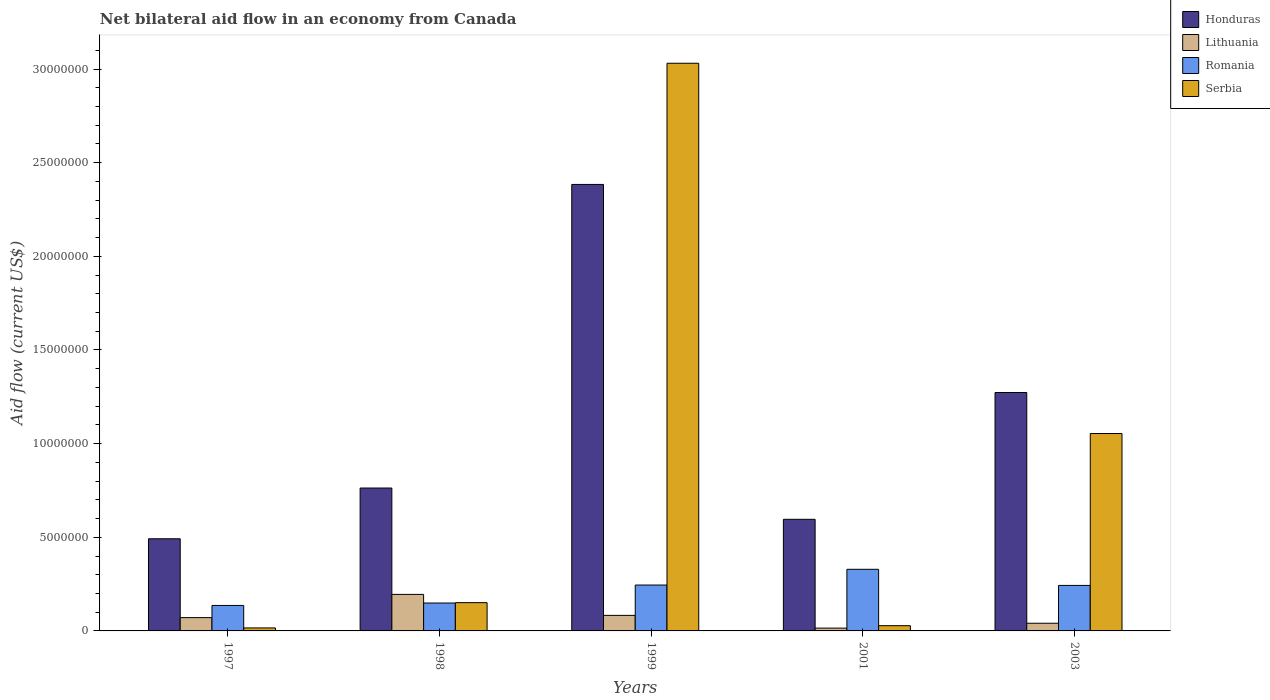How many groups of bars are there?
Offer a terse response. 5. Are the number of bars per tick equal to the number of legend labels?
Offer a very short reply. Yes. How many bars are there on the 4th tick from the left?
Provide a succinct answer. 4. What is the net bilateral aid flow in Serbia in 1999?
Offer a terse response. 3.03e+07. Across all years, what is the maximum net bilateral aid flow in Serbia?
Provide a short and direct response. 3.03e+07. Across all years, what is the minimum net bilateral aid flow in Romania?
Offer a very short reply. 1.36e+06. In which year was the net bilateral aid flow in Lithuania maximum?
Your answer should be compact. 1998. In which year was the net bilateral aid flow in Honduras minimum?
Provide a succinct answer. 1997. What is the total net bilateral aid flow in Serbia in the graph?
Keep it short and to the point. 4.28e+07. What is the difference between the net bilateral aid flow in Serbia in 1997 and that in 1998?
Provide a succinct answer. -1.35e+06. What is the difference between the net bilateral aid flow in Honduras in 2003 and the net bilateral aid flow in Lithuania in 1997?
Your answer should be compact. 1.20e+07. What is the average net bilateral aid flow in Honduras per year?
Your answer should be compact. 1.10e+07. What is the ratio of the net bilateral aid flow in Romania in 1997 to that in 1998?
Offer a very short reply. 0.91. Is the net bilateral aid flow in Serbia in 1999 less than that in 2003?
Your answer should be compact. No. What is the difference between the highest and the second highest net bilateral aid flow in Honduras?
Ensure brevity in your answer.  1.11e+07. What is the difference between the highest and the lowest net bilateral aid flow in Honduras?
Your answer should be compact. 1.89e+07. Is the sum of the net bilateral aid flow in Honduras in 1998 and 2003 greater than the maximum net bilateral aid flow in Serbia across all years?
Your answer should be compact. No. What does the 1st bar from the left in 2001 represents?
Offer a very short reply. Honduras. What does the 4th bar from the right in 1997 represents?
Your response must be concise. Honduras. Is it the case that in every year, the sum of the net bilateral aid flow in Serbia and net bilateral aid flow in Romania is greater than the net bilateral aid flow in Lithuania?
Ensure brevity in your answer.  Yes. How many years are there in the graph?
Ensure brevity in your answer.  5. How many legend labels are there?
Give a very brief answer. 4. What is the title of the graph?
Your response must be concise. Net bilateral aid flow in an economy from Canada. What is the label or title of the X-axis?
Keep it short and to the point. Years. What is the label or title of the Y-axis?
Provide a short and direct response. Aid flow (current US$). What is the Aid flow (current US$) of Honduras in 1997?
Provide a short and direct response. 4.92e+06. What is the Aid flow (current US$) in Lithuania in 1997?
Ensure brevity in your answer.  7.10e+05. What is the Aid flow (current US$) in Romania in 1997?
Make the answer very short. 1.36e+06. What is the Aid flow (current US$) in Serbia in 1997?
Offer a very short reply. 1.60e+05. What is the Aid flow (current US$) of Honduras in 1998?
Your answer should be very brief. 7.63e+06. What is the Aid flow (current US$) in Lithuania in 1998?
Give a very brief answer. 1.95e+06. What is the Aid flow (current US$) in Romania in 1998?
Your answer should be very brief. 1.49e+06. What is the Aid flow (current US$) in Serbia in 1998?
Offer a terse response. 1.51e+06. What is the Aid flow (current US$) in Honduras in 1999?
Give a very brief answer. 2.38e+07. What is the Aid flow (current US$) of Lithuania in 1999?
Your answer should be compact. 8.30e+05. What is the Aid flow (current US$) of Romania in 1999?
Offer a very short reply. 2.45e+06. What is the Aid flow (current US$) of Serbia in 1999?
Offer a very short reply. 3.03e+07. What is the Aid flow (current US$) of Honduras in 2001?
Your answer should be very brief. 5.96e+06. What is the Aid flow (current US$) of Romania in 2001?
Your answer should be very brief. 3.29e+06. What is the Aid flow (current US$) of Honduras in 2003?
Your response must be concise. 1.27e+07. What is the Aid flow (current US$) in Romania in 2003?
Give a very brief answer. 2.43e+06. What is the Aid flow (current US$) in Serbia in 2003?
Give a very brief answer. 1.05e+07. Across all years, what is the maximum Aid flow (current US$) in Honduras?
Keep it short and to the point. 2.38e+07. Across all years, what is the maximum Aid flow (current US$) in Lithuania?
Offer a very short reply. 1.95e+06. Across all years, what is the maximum Aid flow (current US$) in Romania?
Your response must be concise. 3.29e+06. Across all years, what is the maximum Aid flow (current US$) of Serbia?
Make the answer very short. 3.03e+07. Across all years, what is the minimum Aid flow (current US$) in Honduras?
Keep it short and to the point. 4.92e+06. Across all years, what is the minimum Aid flow (current US$) of Romania?
Keep it short and to the point. 1.36e+06. Across all years, what is the minimum Aid flow (current US$) of Serbia?
Keep it short and to the point. 1.60e+05. What is the total Aid flow (current US$) of Honduras in the graph?
Make the answer very short. 5.51e+07. What is the total Aid flow (current US$) in Lithuania in the graph?
Your response must be concise. 4.05e+06. What is the total Aid flow (current US$) in Romania in the graph?
Keep it short and to the point. 1.10e+07. What is the total Aid flow (current US$) of Serbia in the graph?
Make the answer very short. 4.28e+07. What is the difference between the Aid flow (current US$) of Honduras in 1997 and that in 1998?
Make the answer very short. -2.71e+06. What is the difference between the Aid flow (current US$) of Lithuania in 1997 and that in 1998?
Your response must be concise. -1.24e+06. What is the difference between the Aid flow (current US$) of Romania in 1997 and that in 1998?
Your answer should be compact. -1.30e+05. What is the difference between the Aid flow (current US$) in Serbia in 1997 and that in 1998?
Your answer should be very brief. -1.35e+06. What is the difference between the Aid flow (current US$) in Honduras in 1997 and that in 1999?
Make the answer very short. -1.89e+07. What is the difference between the Aid flow (current US$) of Lithuania in 1997 and that in 1999?
Make the answer very short. -1.20e+05. What is the difference between the Aid flow (current US$) of Romania in 1997 and that in 1999?
Your answer should be very brief. -1.09e+06. What is the difference between the Aid flow (current US$) of Serbia in 1997 and that in 1999?
Ensure brevity in your answer.  -3.02e+07. What is the difference between the Aid flow (current US$) in Honduras in 1997 and that in 2001?
Keep it short and to the point. -1.04e+06. What is the difference between the Aid flow (current US$) in Lithuania in 1997 and that in 2001?
Your answer should be very brief. 5.60e+05. What is the difference between the Aid flow (current US$) of Romania in 1997 and that in 2001?
Ensure brevity in your answer.  -1.93e+06. What is the difference between the Aid flow (current US$) in Serbia in 1997 and that in 2001?
Offer a terse response. -1.20e+05. What is the difference between the Aid flow (current US$) in Honduras in 1997 and that in 2003?
Offer a terse response. -7.81e+06. What is the difference between the Aid flow (current US$) of Romania in 1997 and that in 2003?
Your response must be concise. -1.07e+06. What is the difference between the Aid flow (current US$) of Serbia in 1997 and that in 2003?
Keep it short and to the point. -1.04e+07. What is the difference between the Aid flow (current US$) in Honduras in 1998 and that in 1999?
Offer a very short reply. -1.62e+07. What is the difference between the Aid flow (current US$) in Lithuania in 1998 and that in 1999?
Provide a short and direct response. 1.12e+06. What is the difference between the Aid flow (current US$) in Romania in 1998 and that in 1999?
Give a very brief answer. -9.60e+05. What is the difference between the Aid flow (current US$) of Serbia in 1998 and that in 1999?
Ensure brevity in your answer.  -2.88e+07. What is the difference between the Aid flow (current US$) of Honduras in 1998 and that in 2001?
Your response must be concise. 1.67e+06. What is the difference between the Aid flow (current US$) in Lithuania in 1998 and that in 2001?
Make the answer very short. 1.80e+06. What is the difference between the Aid flow (current US$) in Romania in 1998 and that in 2001?
Your answer should be compact. -1.80e+06. What is the difference between the Aid flow (current US$) of Serbia in 1998 and that in 2001?
Your response must be concise. 1.23e+06. What is the difference between the Aid flow (current US$) of Honduras in 1998 and that in 2003?
Keep it short and to the point. -5.10e+06. What is the difference between the Aid flow (current US$) in Lithuania in 1998 and that in 2003?
Your answer should be compact. 1.54e+06. What is the difference between the Aid flow (current US$) of Romania in 1998 and that in 2003?
Your answer should be very brief. -9.40e+05. What is the difference between the Aid flow (current US$) of Serbia in 1998 and that in 2003?
Keep it short and to the point. -9.03e+06. What is the difference between the Aid flow (current US$) of Honduras in 1999 and that in 2001?
Your answer should be very brief. 1.79e+07. What is the difference between the Aid flow (current US$) of Lithuania in 1999 and that in 2001?
Your answer should be compact. 6.80e+05. What is the difference between the Aid flow (current US$) in Romania in 1999 and that in 2001?
Make the answer very short. -8.40e+05. What is the difference between the Aid flow (current US$) of Serbia in 1999 and that in 2001?
Keep it short and to the point. 3.00e+07. What is the difference between the Aid flow (current US$) in Honduras in 1999 and that in 2003?
Your response must be concise. 1.11e+07. What is the difference between the Aid flow (current US$) of Lithuania in 1999 and that in 2003?
Offer a very short reply. 4.20e+05. What is the difference between the Aid flow (current US$) of Romania in 1999 and that in 2003?
Keep it short and to the point. 2.00e+04. What is the difference between the Aid flow (current US$) in Serbia in 1999 and that in 2003?
Your response must be concise. 1.98e+07. What is the difference between the Aid flow (current US$) in Honduras in 2001 and that in 2003?
Your answer should be compact. -6.77e+06. What is the difference between the Aid flow (current US$) in Romania in 2001 and that in 2003?
Provide a succinct answer. 8.60e+05. What is the difference between the Aid flow (current US$) of Serbia in 2001 and that in 2003?
Keep it short and to the point. -1.03e+07. What is the difference between the Aid flow (current US$) in Honduras in 1997 and the Aid flow (current US$) in Lithuania in 1998?
Offer a very short reply. 2.97e+06. What is the difference between the Aid flow (current US$) in Honduras in 1997 and the Aid flow (current US$) in Romania in 1998?
Offer a terse response. 3.43e+06. What is the difference between the Aid flow (current US$) in Honduras in 1997 and the Aid flow (current US$) in Serbia in 1998?
Your answer should be compact. 3.41e+06. What is the difference between the Aid flow (current US$) in Lithuania in 1997 and the Aid flow (current US$) in Romania in 1998?
Give a very brief answer. -7.80e+05. What is the difference between the Aid flow (current US$) of Lithuania in 1997 and the Aid flow (current US$) of Serbia in 1998?
Your response must be concise. -8.00e+05. What is the difference between the Aid flow (current US$) in Romania in 1997 and the Aid flow (current US$) in Serbia in 1998?
Keep it short and to the point. -1.50e+05. What is the difference between the Aid flow (current US$) in Honduras in 1997 and the Aid flow (current US$) in Lithuania in 1999?
Give a very brief answer. 4.09e+06. What is the difference between the Aid flow (current US$) in Honduras in 1997 and the Aid flow (current US$) in Romania in 1999?
Your response must be concise. 2.47e+06. What is the difference between the Aid flow (current US$) in Honduras in 1997 and the Aid flow (current US$) in Serbia in 1999?
Offer a terse response. -2.54e+07. What is the difference between the Aid flow (current US$) of Lithuania in 1997 and the Aid flow (current US$) of Romania in 1999?
Give a very brief answer. -1.74e+06. What is the difference between the Aid flow (current US$) in Lithuania in 1997 and the Aid flow (current US$) in Serbia in 1999?
Provide a short and direct response. -2.96e+07. What is the difference between the Aid flow (current US$) in Romania in 1997 and the Aid flow (current US$) in Serbia in 1999?
Provide a short and direct response. -2.90e+07. What is the difference between the Aid flow (current US$) of Honduras in 1997 and the Aid flow (current US$) of Lithuania in 2001?
Your answer should be compact. 4.77e+06. What is the difference between the Aid flow (current US$) of Honduras in 1997 and the Aid flow (current US$) of Romania in 2001?
Provide a succinct answer. 1.63e+06. What is the difference between the Aid flow (current US$) of Honduras in 1997 and the Aid flow (current US$) of Serbia in 2001?
Give a very brief answer. 4.64e+06. What is the difference between the Aid flow (current US$) of Lithuania in 1997 and the Aid flow (current US$) of Romania in 2001?
Your answer should be compact. -2.58e+06. What is the difference between the Aid flow (current US$) in Lithuania in 1997 and the Aid flow (current US$) in Serbia in 2001?
Your answer should be very brief. 4.30e+05. What is the difference between the Aid flow (current US$) in Romania in 1997 and the Aid flow (current US$) in Serbia in 2001?
Your response must be concise. 1.08e+06. What is the difference between the Aid flow (current US$) of Honduras in 1997 and the Aid flow (current US$) of Lithuania in 2003?
Make the answer very short. 4.51e+06. What is the difference between the Aid flow (current US$) in Honduras in 1997 and the Aid flow (current US$) in Romania in 2003?
Ensure brevity in your answer.  2.49e+06. What is the difference between the Aid flow (current US$) of Honduras in 1997 and the Aid flow (current US$) of Serbia in 2003?
Make the answer very short. -5.62e+06. What is the difference between the Aid flow (current US$) in Lithuania in 1997 and the Aid flow (current US$) in Romania in 2003?
Ensure brevity in your answer.  -1.72e+06. What is the difference between the Aid flow (current US$) of Lithuania in 1997 and the Aid flow (current US$) of Serbia in 2003?
Offer a terse response. -9.83e+06. What is the difference between the Aid flow (current US$) of Romania in 1997 and the Aid flow (current US$) of Serbia in 2003?
Ensure brevity in your answer.  -9.18e+06. What is the difference between the Aid flow (current US$) in Honduras in 1998 and the Aid flow (current US$) in Lithuania in 1999?
Your response must be concise. 6.80e+06. What is the difference between the Aid flow (current US$) of Honduras in 1998 and the Aid flow (current US$) of Romania in 1999?
Your response must be concise. 5.18e+06. What is the difference between the Aid flow (current US$) in Honduras in 1998 and the Aid flow (current US$) in Serbia in 1999?
Make the answer very short. -2.27e+07. What is the difference between the Aid flow (current US$) of Lithuania in 1998 and the Aid flow (current US$) of Romania in 1999?
Ensure brevity in your answer.  -5.00e+05. What is the difference between the Aid flow (current US$) of Lithuania in 1998 and the Aid flow (current US$) of Serbia in 1999?
Offer a very short reply. -2.84e+07. What is the difference between the Aid flow (current US$) in Romania in 1998 and the Aid flow (current US$) in Serbia in 1999?
Provide a succinct answer. -2.88e+07. What is the difference between the Aid flow (current US$) of Honduras in 1998 and the Aid flow (current US$) of Lithuania in 2001?
Give a very brief answer. 7.48e+06. What is the difference between the Aid flow (current US$) in Honduras in 1998 and the Aid flow (current US$) in Romania in 2001?
Offer a terse response. 4.34e+06. What is the difference between the Aid flow (current US$) of Honduras in 1998 and the Aid flow (current US$) of Serbia in 2001?
Give a very brief answer. 7.35e+06. What is the difference between the Aid flow (current US$) in Lithuania in 1998 and the Aid flow (current US$) in Romania in 2001?
Provide a short and direct response. -1.34e+06. What is the difference between the Aid flow (current US$) in Lithuania in 1998 and the Aid flow (current US$) in Serbia in 2001?
Your answer should be very brief. 1.67e+06. What is the difference between the Aid flow (current US$) of Romania in 1998 and the Aid flow (current US$) of Serbia in 2001?
Offer a terse response. 1.21e+06. What is the difference between the Aid flow (current US$) of Honduras in 1998 and the Aid flow (current US$) of Lithuania in 2003?
Your response must be concise. 7.22e+06. What is the difference between the Aid flow (current US$) of Honduras in 1998 and the Aid flow (current US$) of Romania in 2003?
Offer a terse response. 5.20e+06. What is the difference between the Aid flow (current US$) in Honduras in 1998 and the Aid flow (current US$) in Serbia in 2003?
Provide a succinct answer. -2.91e+06. What is the difference between the Aid flow (current US$) in Lithuania in 1998 and the Aid flow (current US$) in Romania in 2003?
Offer a very short reply. -4.80e+05. What is the difference between the Aid flow (current US$) of Lithuania in 1998 and the Aid flow (current US$) of Serbia in 2003?
Your response must be concise. -8.59e+06. What is the difference between the Aid flow (current US$) of Romania in 1998 and the Aid flow (current US$) of Serbia in 2003?
Give a very brief answer. -9.05e+06. What is the difference between the Aid flow (current US$) in Honduras in 1999 and the Aid flow (current US$) in Lithuania in 2001?
Give a very brief answer. 2.37e+07. What is the difference between the Aid flow (current US$) in Honduras in 1999 and the Aid flow (current US$) in Romania in 2001?
Make the answer very short. 2.06e+07. What is the difference between the Aid flow (current US$) in Honduras in 1999 and the Aid flow (current US$) in Serbia in 2001?
Your answer should be compact. 2.36e+07. What is the difference between the Aid flow (current US$) in Lithuania in 1999 and the Aid flow (current US$) in Romania in 2001?
Offer a very short reply. -2.46e+06. What is the difference between the Aid flow (current US$) of Lithuania in 1999 and the Aid flow (current US$) of Serbia in 2001?
Keep it short and to the point. 5.50e+05. What is the difference between the Aid flow (current US$) in Romania in 1999 and the Aid flow (current US$) in Serbia in 2001?
Your response must be concise. 2.17e+06. What is the difference between the Aid flow (current US$) of Honduras in 1999 and the Aid flow (current US$) of Lithuania in 2003?
Make the answer very short. 2.34e+07. What is the difference between the Aid flow (current US$) in Honduras in 1999 and the Aid flow (current US$) in Romania in 2003?
Keep it short and to the point. 2.14e+07. What is the difference between the Aid flow (current US$) in Honduras in 1999 and the Aid flow (current US$) in Serbia in 2003?
Provide a short and direct response. 1.33e+07. What is the difference between the Aid flow (current US$) in Lithuania in 1999 and the Aid flow (current US$) in Romania in 2003?
Make the answer very short. -1.60e+06. What is the difference between the Aid flow (current US$) in Lithuania in 1999 and the Aid flow (current US$) in Serbia in 2003?
Your response must be concise. -9.71e+06. What is the difference between the Aid flow (current US$) in Romania in 1999 and the Aid flow (current US$) in Serbia in 2003?
Your answer should be compact. -8.09e+06. What is the difference between the Aid flow (current US$) in Honduras in 2001 and the Aid flow (current US$) in Lithuania in 2003?
Offer a very short reply. 5.55e+06. What is the difference between the Aid flow (current US$) of Honduras in 2001 and the Aid flow (current US$) of Romania in 2003?
Give a very brief answer. 3.53e+06. What is the difference between the Aid flow (current US$) of Honduras in 2001 and the Aid flow (current US$) of Serbia in 2003?
Your answer should be very brief. -4.58e+06. What is the difference between the Aid flow (current US$) in Lithuania in 2001 and the Aid flow (current US$) in Romania in 2003?
Offer a very short reply. -2.28e+06. What is the difference between the Aid flow (current US$) in Lithuania in 2001 and the Aid flow (current US$) in Serbia in 2003?
Your response must be concise. -1.04e+07. What is the difference between the Aid flow (current US$) of Romania in 2001 and the Aid flow (current US$) of Serbia in 2003?
Offer a very short reply. -7.25e+06. What is the average Aid flow (current US$) in Honduras per year?
Keep it short and to the point. 1.10e+07. What is the average Aid flow (current US$) of Lithuania per year?
Give a very brief answer. 8.10e+05. What is the average Aid flow (current US$) in Romania per year?
Offer a terse response. 2.20e+06. What is the average Aid flow (current US$) in Serbia per year?
Offer a very short reply. 8.56e+06. In the year 1997, what is the difference between the Aid flow (current US$) of Honduras and Aid flow (current US$) of Lithuania?
Make the answer very short. 4.21e+06. In the year 1997, what is the difference between the Aid flow (current US$) in Honduras and Aid flow (current US$) in Romania?
Your answer should be compact. 3.56e+06. In the year 1997, what is the difference between the Aid flow (current US$) of Honduras and Aid flow (current US$) of Serbia?
Ensure brevity in your answer.  4.76e+06. In the year 1997, what is the difference between the Aid flow (current US$) in Lithuania and Aid flow (current US$) in Romania?
Keep it short and to the point. -6.50e+05. In the year 1997, what is the difference between the Aid flow (current US$) of Lithuania and Aid flow (current US$) of Serbia?
Offer a very short reply. 5.50e+05. In the year 1997, what is the difference between the Aid flow (current US$) in Romania and Aid flow (current US$) in Serbia?
Make the answer very short. 1.20e+06. In the year 1998, what is the difference between the Aid flow (current US$) in Honduras and Aid flow (current US$) in Lithuania?
Provide a short and direct response. 5.68e+06. In the year 1998, what is the difference between the Aid flow (current US$) of Honduras and Aid flow (current US$) of Romania?
Your answer should be compact. 6.14e+06. In the year 1998, what is the difference between the Aid flow (current US$) in Honduras and Aid flow (current US$) in Serbia?
Provide a succinct answer. 6.12e+06. In the year 1998, what is the difference between the Aid flow (current US$) in Romania and Aid flow (current US$) in Serbia?
Make the answer very short. -2.00e+04. In the year 1999, what is the difference between the Aid flow (current US$) of Honduras and Aid flow (current US$) of Lithuania?
Make the answer very short. 2.30e+07. In the year 1999, what is the difference between the Aid flow (current US$) of Honduras and Aid flow (current US$) of Romania?
Give a very brief answer. 2.14e+07. In the year 1999, what is the difference between the Aid flow (current US$) in Honduras and Aid flow (current US$) in Serbia?
Make the answer very short. -6.47e+06. In the year 1999, what is the difference between the Aid flow (current US$) of Lithuania and Aid flow (current US$) of Romania?
Ensure brevity in your answer.  -1.62e+06. In the year 1999, what is the difference between the Aid flow (current US$) in Lithuania and Aid flow (current US$) in Serbia?
Offer a very short reply. -2.95e+07. In the year 1999, what is the difference between the Aid flow (current US$) in Romania and Aid flow (current US$) in Serbia?
Ensure brevity in your answer.  -2.79e+07. In the year 2001, what is the difference between the Aid flow (current US$) of Honduras and Aid flow (current US$) of Lithuania?
Offer a terse response. 5.81e+06. In the year 2001, what is the difference between the Aid flow (current US$) of Honduras and Aid flow (current US$) of Romania?
Keep it short and to the point. 2.67e+06. In the year 2001, what is the difference between the Aid flow (current US$) of Honduras and Aid flow (current US$) of Serbia?
Give a very brief answer. 5.68e+06. In the year 2001, what is the difference between the Aid flow (current US$) of Lithuania and Aid flow (current US$) of Romania?
Offer a terse response. -3.14e+06. In the year 2001, what is the difference between the Aid flow (current US$) of Lithuania and Aid flow (current US$) of Serbia?
Give a very brief answer. -1.30e+05. In the year 2001, what is the difference between the Aid flow (current US$) of Romania and Aid flow (current US$) of Serbia?
Offer a terse response. 3.01e+06. In the year 2003, what is the difference between the Aid flow (current US$) of Honduras and Aid flow (current US$) of Lithuania?
Provide a succinct answer. 1.23e+07. In the year 2003, what is the difference between the Aid flow (current US$) of Honduras and Aid flow (current US$) of Romania?
Your answer should be very brief. 1.03e+07. In the year 2003, what is the difference between the Aid flow (current US$) of Honduras and Aid flow (current US$) of Serbia?
Make the answer very short. 2.19e+06. In the year 2003, what is the difference between the Aid flow (current US$) in Lithuania and Aid flow (current US$) in Romania?
Your answer should be very brief. -2.02e+06. In the year 2003, what is the difference between the Aid flow (current US$) in Lithuania and Aid flow (current US$) in Serbia?
Keep it short and to the point. -1.01e+07. In the year 2003, what is the difference between the Aid flow (current US$) of Romania and Aid flow (current US$) of Serbia?
Offer a very short reply. -8.11e+06. What is the ratio of the Aid flow (current US$) in Honduras in 1997 to that in 1998?
Offer a terse response. 0.64. What is the ratio of the Aid flow (current US$) of Lithuania in 1997 to that in 1998?
Your response must be concise. 0.36. What is the ratio of the Aid flow (current US$) in Romania in 1997 to that in 1998?
Keep it short and to the point. 0.91. What is the ratio of the Aid flow (current US$) of Serbia in 1997 to that in 1998?
Your response must be concise. 0.11. What is the ratio of the Aid flow (current US$) of Honduras in 1997 to that in 1999?
Your response must be concise. 0.21. What is the ratio of the Aid flow (current US$) of Lithuania in 1997 to that in 1999?
Your answer should be very brief. 0.86. What is the ratio of the Aid flow (current US$) of Romania in 1997 to that in 1999?
Offer a very short reply. 0.56. What is the ratio of the Aid flow (current US$) of Serbia in 1997 to that in 1999?
Your answer should be very brief. 0.01. What is the ratio of the Aid flow (current US$) of Honduras in 1997 to that in 2001?
Offer a terse response. 0.83. What is the ratio of the Aid flow (current US$) of Lithuania in 1997 to that in 2001?
Keep it short and to the point. 4.73. What is the ratio of the Aid flow (current US$) of Romania in 1997 to that in 2001?
Provide a short and direct response. 0.41. What is the ratio of the Aid flow (current US$) of Serbia in 1997 to that in 2001?
Your answer should be very brief. 0.57. What is the ratio of the Aid flow (current US$) in Honduras in 1997 to that in 2003?
Offer a very short reply. 0.39. What is the ratio of the Aid flow (current US$) in Lithuania in 1997 to that in 2003?
Offer a terse response. 1.73. What is the ratio of the Aid flow (current US$) of Romania in 1997 to that in 2003?
Your answer should be very brief. 0.56. What is the ratio of the Aid flow (current US$) of Serbia in 1997 to that in 2003?
Ensure brevity in your answer.  0.02. What is the ratio of the Aid flow (current US$) in Honduras in 1998 to that in 1999?
Provide a succinct answer. 0.32. What is the ratio of the Aid flow (current US$) in Lithuania in 1998 to that in 1999?
Offer a very short reply. 2.35. What is the ratio of the Aid flow (current US$) of Romania in 1998 to that in 1999?
Ensure brevity in your answer.  0.61. What is the ratio of the Aid flow (current US$) in Serbia in 1998 to that in 1999?
Give a very brief answer. 0.05. What is the ratio of the Aid flow (current US$) of Honduras in 1998 to that in 2001?
Give a very brief answer. 1.28. What is the ratio of the Aid flow (current US$) of Romania in 1998 to that in 2001?
Ensure brevity in your answer.  0.45. What is the ratio of the Aid flow (current US$) in Serbia in 1998 to that in 2001?
Offer a very short reply. 5.39. What is the ratio of the Aid flow (current US$) in Honduras in 1998 to that in 2003?
Your answer should be compact. 0.6. What is the ratio of the Aid flow (current US$) of Lithuania in 1998 to that in 2003?
Your answer should be very brief. 4.76. What is the ratio of the Aid flow (current US$) of Romania in 1998 to that in 2003?
Provide a succinct answer. 0.61. What is the ratio of the Aid flow (current US$) in Serbia in 1998 to that in 2003?
Offer a terse response. 0.14. What is the ratio of the Aid flow (current US$) of Honduras in 1999 to that in 2001?
Make the answer very short. 4. What is the ratio of the Aid flow (current US$) in Lithuania in 1999 to that in 2001?
Give a very brief answer. 5.53. What is the ratio of the Aid flow (current US$) of Romania in 1999 to that in 2001?
Give a very brief answer. 0.74. What is the ratio of the Aid flow (current US$) of Serbia in 1999 to that in 2001?
Offer a terse response. 108.25. What is the ratio of the Aid flow (current US$) in Honduras in 1999 to that in 2003?
Your response must be concise. 1.87. What is the ratio of the Aid flow (current US$) in Lithuania in 1999 to that in 2003?
Give a very brief answer. 2.02. What is the ratio of the Aid flow (current US$) in Romania in 1999 to that in 2003?
Make the answer very short. 1.01. What is the ratio of the Aid flow (current US$) in Serbia in 1999 to that in 2003?
Make the answer very short. 2.88. What is the ratio of the Aid flow (current US$) in Honduras in 2001 to that in 2003?
Your answer should be very brief. 0.47. What is the ratio of the Aid flow (current US$) in Lithuania in 2001 to that in 2003?
Provide a short and direct response. 0.37. What is the ratio of the Aid flow (current US$) of Romania in 2001 to that in 2003?
Make the answer very short. 1.35. What is the ratio of the Aid flow (current US$) in Serbia in 2001 to that in 2003?
Your response must be concise. 0.03. What is the difference between the highest and the second highest Aid flow (current US$) of Honduras?
Ensure brevity in your answer.  1.11e+07. What is the difference between the highest and the second highest Aid flow (current US$) in Lithuania?
Your answer should be very brief. 1.12e+06. What is the difference between the highest and the second highest Aid flow (current US$) of Romania?
Provide a succinct answer. 8.40e+05. What is the difference between the highest and the second highest Aid flow (current US$) of Serbia?
Make the answer very short. 1.98e+07. What is the difference between the highest and the lowest Aid flow (current US$) of Honduras?
Your response must be concise. 1.89e+07. What is the difference between the highest and the lowest Aid flow (current US$) in Lithuania?
Provide a short and direct response. 1.80e+06. What is the difference between the highest and the lowest Aid flow (current US$) in Romania?
Provide a short and direct response. 1.93e+06. What is the difference between the highest and the lowest Aid flow (current US$) of Serbia?
Provide a succinct answer. 3.02e+07. 